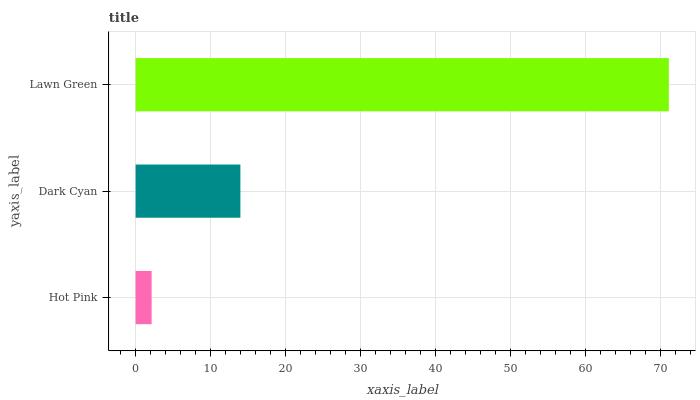Is Hot Pink the minimum?
Answer yes or no. Yes. Is Lawn Green the maximum?
Answer yes or no. Yes. Is Dark Cyan the minimum?
Answer yes or no. No. Is Dark Cyan the maximum?
Answer yes or no. No. Is Dark Cyan greater than Hot Pink?
Answer yes or no. Yes. Is Hot Pink less than Dark Cyan?
Answer yes or no. Yes. Is Hot Pink greater than Dark Cyan?
Answer yes or no. No. Is Dark Cyan less than Hot Pink?
Answer yes or no. No. Is Dark Cyan the high median?
Answer yes or no. Yes. Is Dark Cyan the low median?
Answer yes or no. Yes. Is Hot Pink the high median?
Answer yes or no. No. Is Hot Pink the low median?
Answer yes or no. No. 